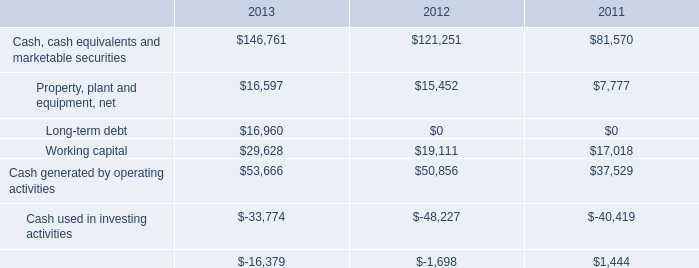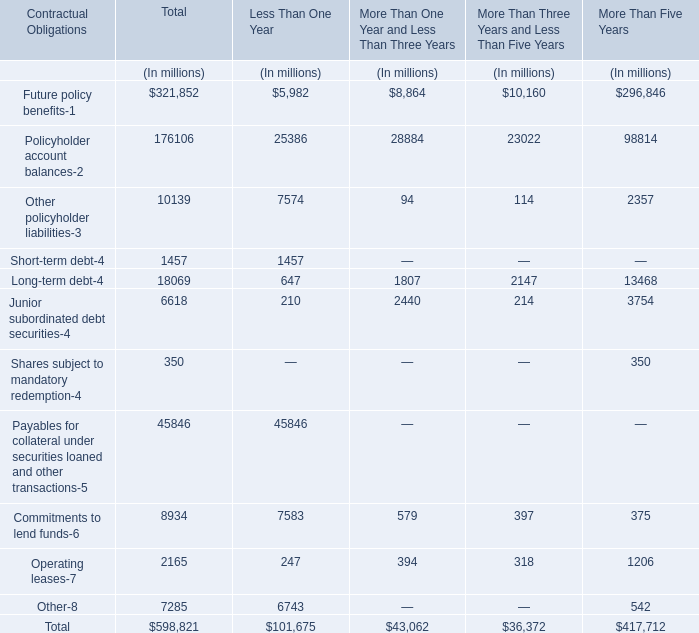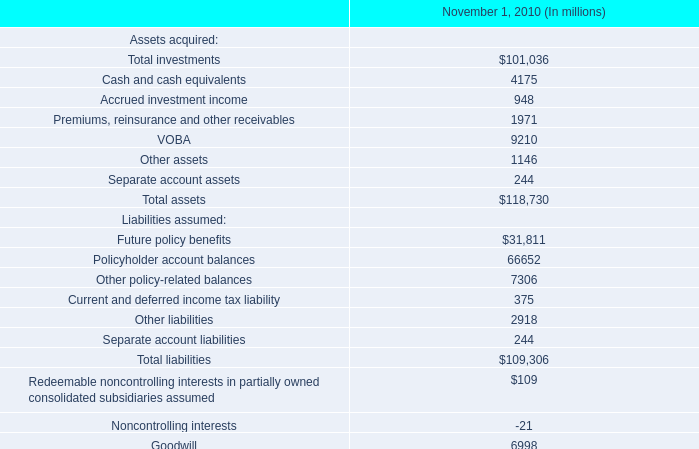cash used in investing activities during 2012 was $ 48.2 billion . what percentage of this consisted of cash used to acquire property , plant and equipment? 
Computations: (8.3 / 48.2)
Answer: 0.1722. 